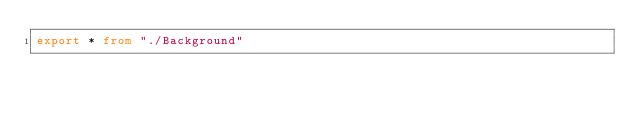<code> <loc_0><loc_0><loc_500><loc_500><_TypeScript_>export * from "./Background"
</code> 